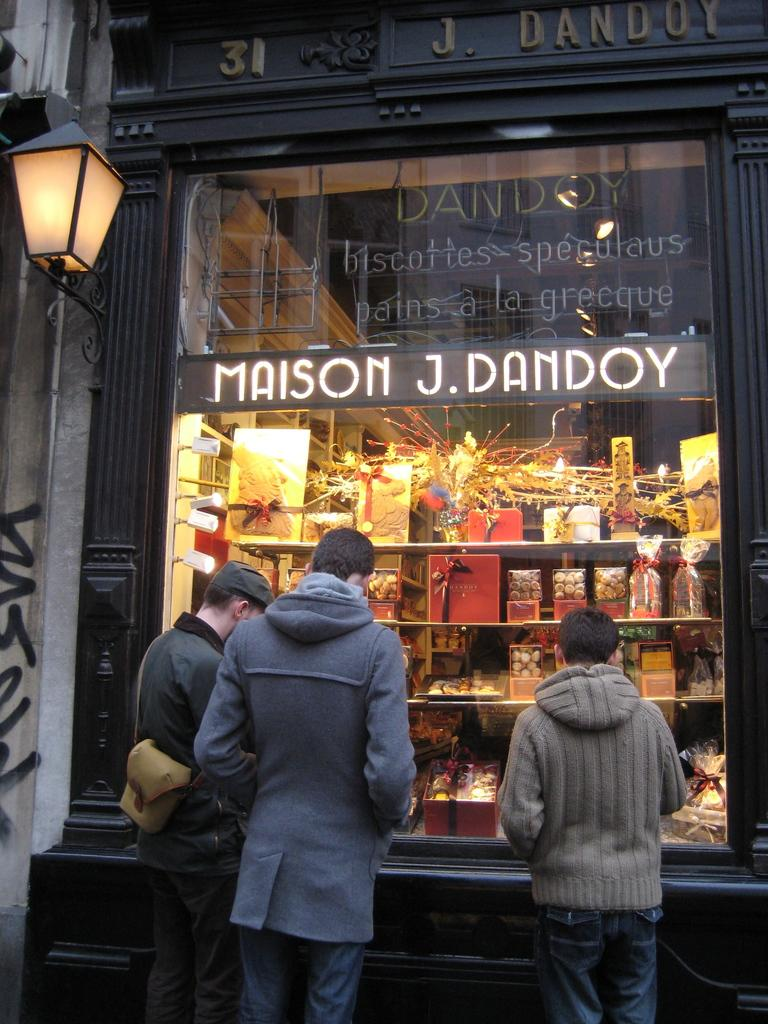How many people are in front of the building in the image? There are three people standing in front of the building. What type of establishment is located inside the building? There is a shop inside the building. What color is the feather on the beast in the image? There is no beast or feather present in the image. 